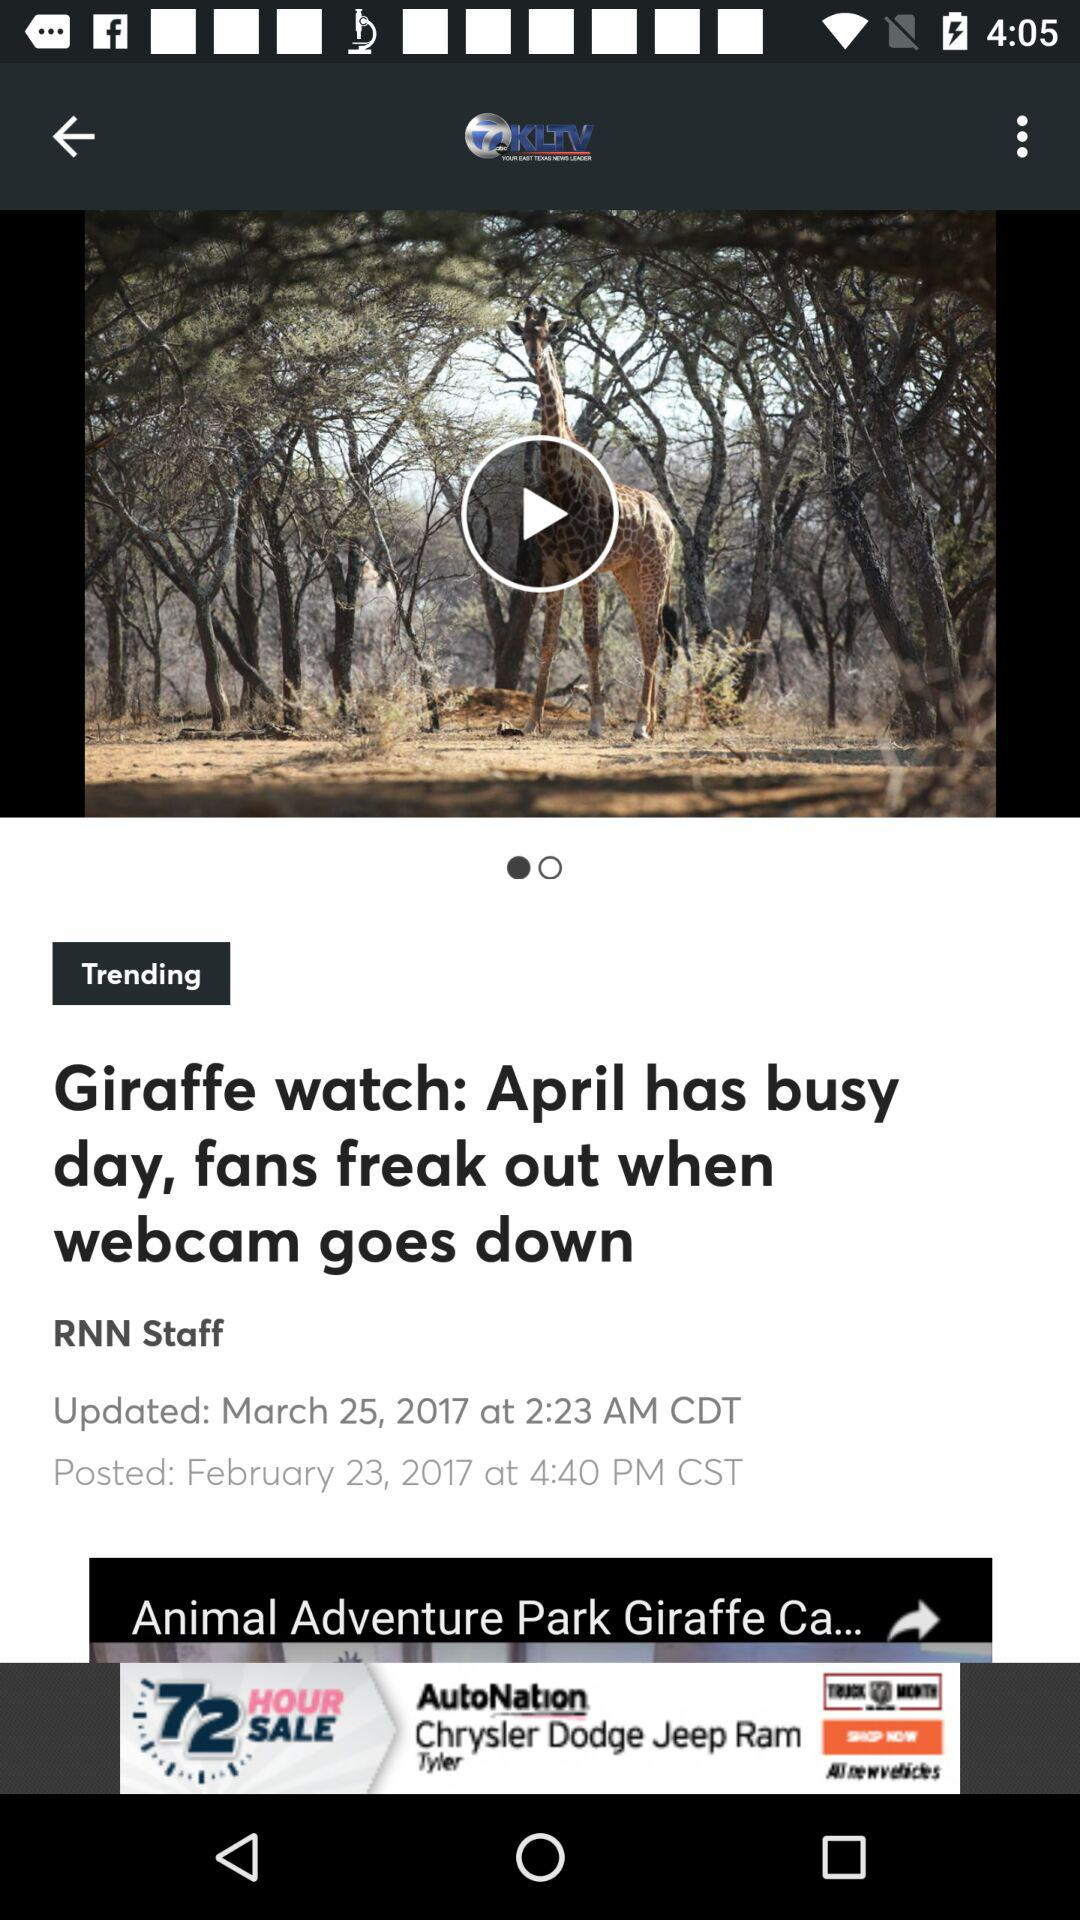When was "Giraffe watch: April has busy day, fans freak out when webcam goes down" updated? "Giraffe watch: April has busy day, fans freak out when webcam goes down" was updated on March 25, 2017 at 2:23 AM in the Central Daylight Time. 